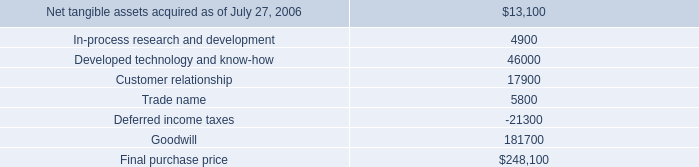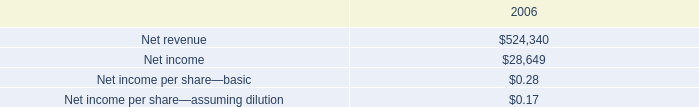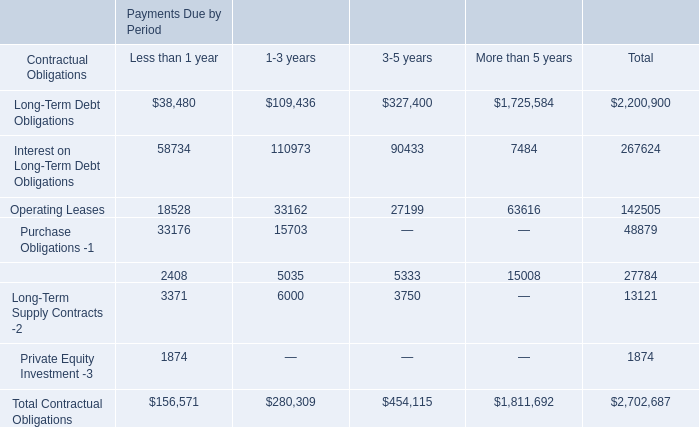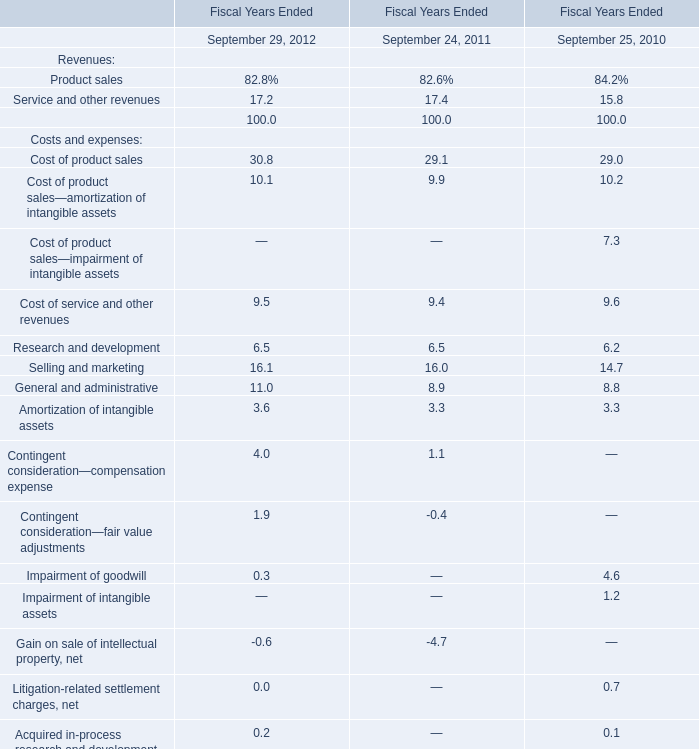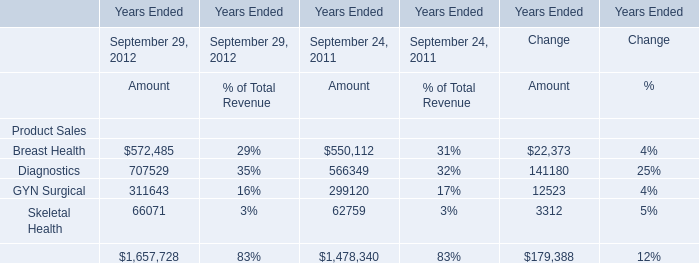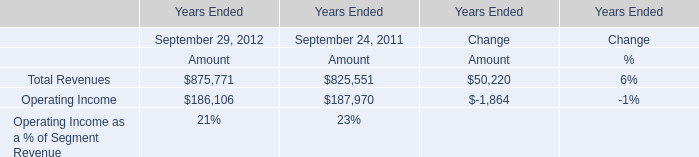Does the value of Diagnostics in 2011 greater than that in 2012? 
Answer: No. 